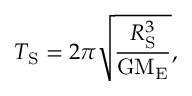<formula> <loc_0><loc_0><loc_500><loc_500>T _ { S } = 2 \pi \sqrt { \frac { R _ { S } ^ { 3 } } { G M _ { E } } } ,</formula> 